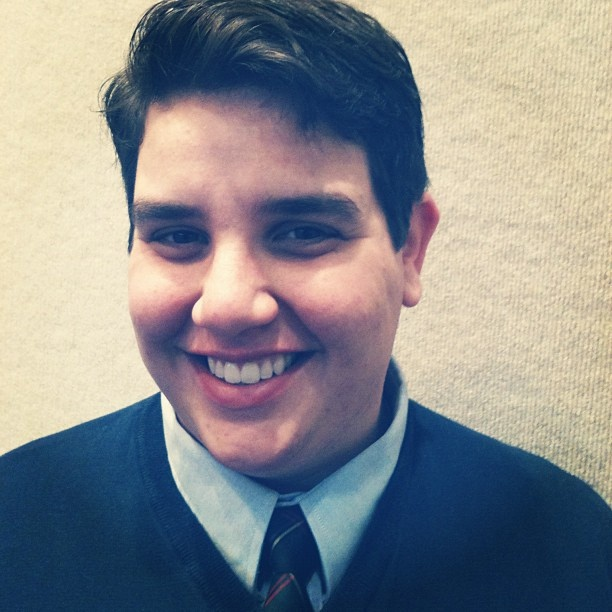Describe the objects in this image and their specific colors. I can see people in beige, navy, gray, blue, and lightpink tones and tie in beige, navy, blue, and purple tones in this image. 